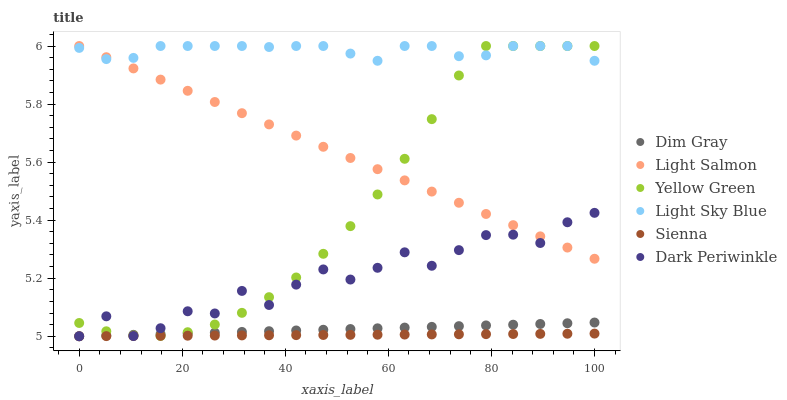Does Sienna have the minimum area under the curve?
Answer yes or no. Yes. Does Light Sky Blue have the maximum area under the curve?
Answer yes or no. Yes. Does Dim Gray have the minimum area under the curve?
Answer yes or no. No. Does Dim Gray have the maximum area under the curve?
Answer yes or no. No. Is Light Salmon the smoothest?
Answer yes or no. Yes. Is Dark Periwinkle the roughest?
Answer yes or no. Yes. Is Dim Gray the smoothest?
Answer yes or no. No. Is Dim Gray the roughest?
Answer yes or no. No. Does Dim Gray have the lowest value?
Answer yes or no. Yes. Does Yellow Green have the lowest value?
Answer yes or no. No. Does Light Sky Blue have the highest value?
Answer yes or no. Yes. Does Dim Gray have the highest value?
Answer yes or no. No. Is Sienna less than Light Salmon?
Answer yes or no. Yes. Is Light Sky Blue greater than Sienna?
Answer yes or no. Yes. Does Light Sky Blue intersect Yellow Green?
Answer yes or no. Yes. Is Light Sky Blue less than Yellow Green?
Answer yes or no. No. Is Light Sky Blue greater than Yellow Green?
Answer yes or no. No. Does Sienna intersect Light Salmon?
Answer yes or no. No. 